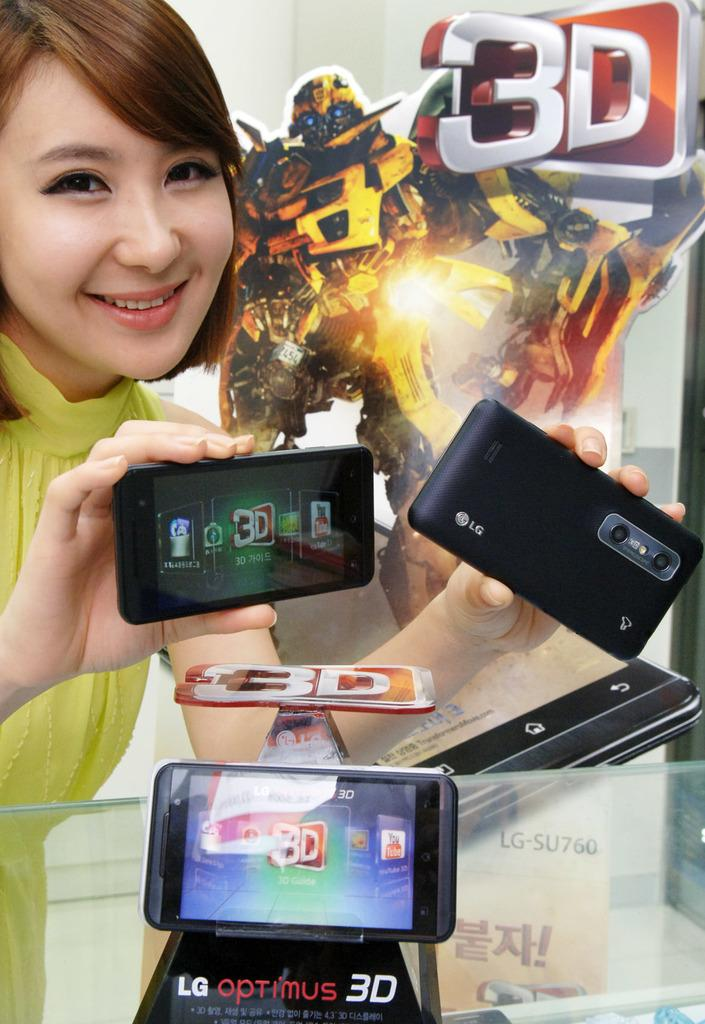<image>
Give a short and clear explanation of the subsequent image. A woman holding two phones over a display model of an LG Optimus 3D. 